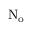Convert formula to latex. <formula><loc_0><loc_0><loc_500><loc_500>N _ { o }</formula> 